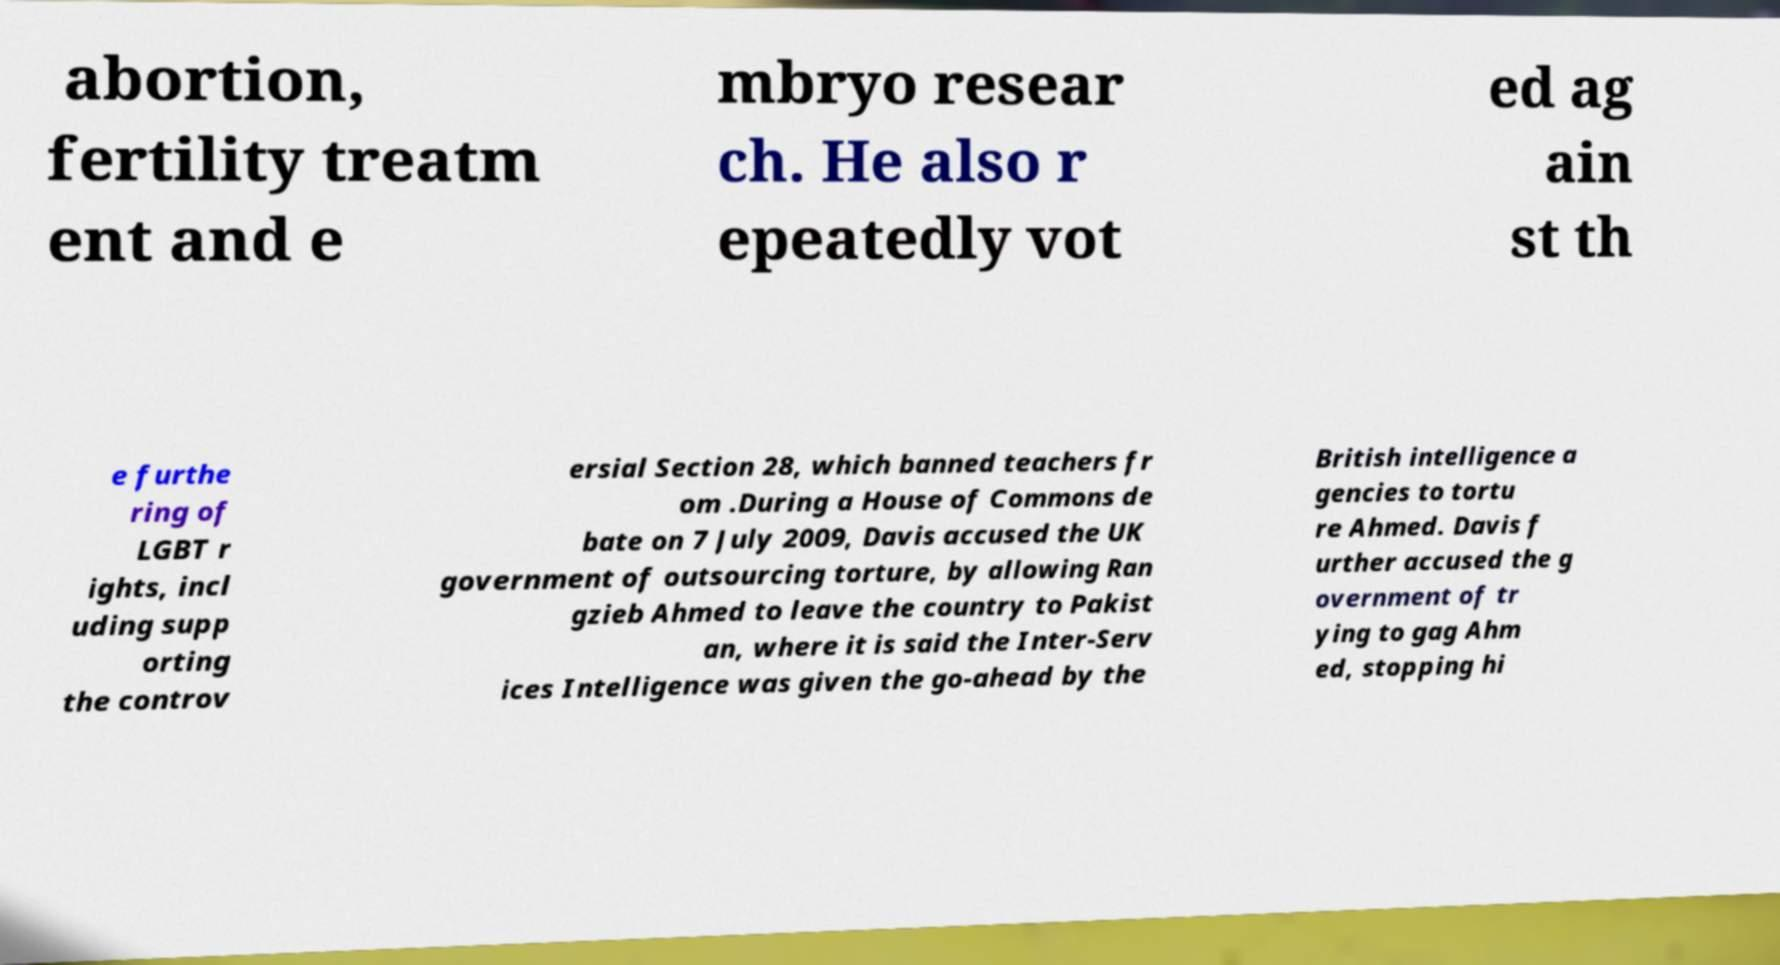For documentation purposes, I need the text within this image transcribed. Could you provide that? abortion, fertility treatm ent and e mbryo resear ch. He also r epeatedly vot ed ag ain st th e furthe ring of LGBT r ights, incl uding supp orting the controv ersial Section 28, which banned teachers fr om .During a House of Commons de bate on 7 July 2009, Davis accused the UK government of outsourcing torture, by allowing Ran gzieb Ahmed to leave the country to Pakist an, where it is said the Inter-Serv ices Intelligence was given the go-ahead by the British intelligence a gencies to tortu re Ahmed. Davis f urther accused the g overnment of tr ying to gag Ahm ed, stopping hi 